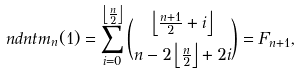Convert formula to latex. <formula><loc_0><loc_0><loc_500><loc_500>\ n d n t m _ { n } ( 1 ) = \sum _ { i = 0 } ^ { \left \lfloor \frac { n } { 2 } \right \rfloor } \binom { \left \lfloor \frac { n + 1 } { 2 } + i \right \rfloor } { n - 2 \left \lfloor \frac { n } { 2 } \right \rfloor + 2 i } = F _ { n + 1 } ,</formula> 